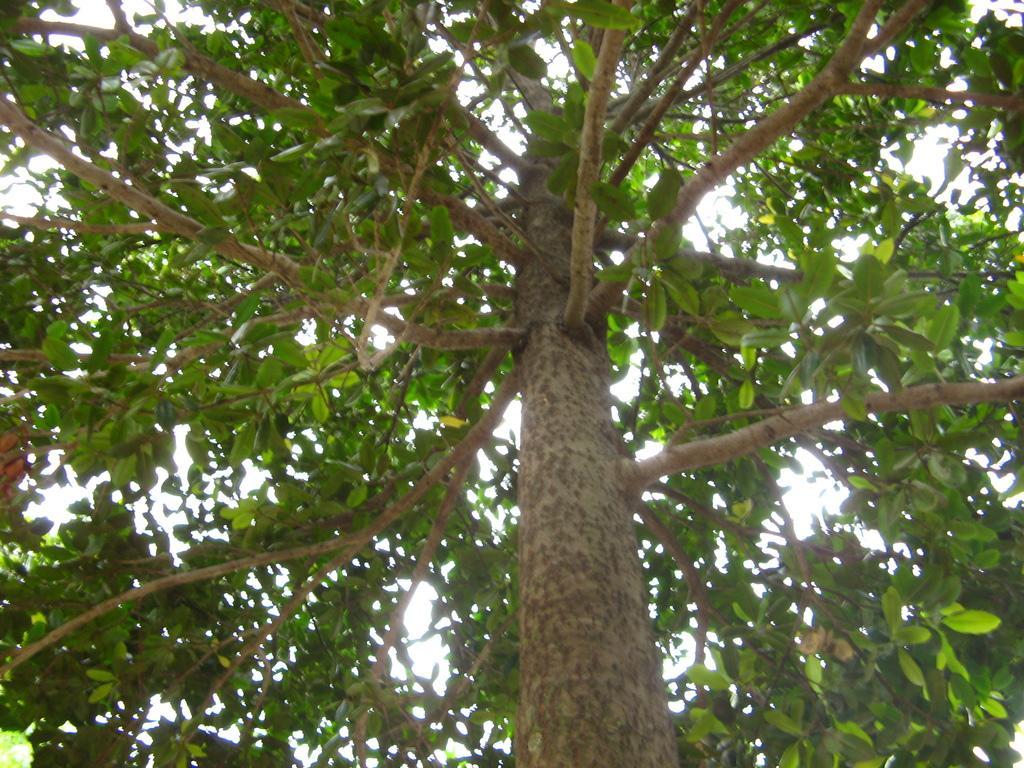Can you describe this image briefly? In this image I can see a tree which is green and brown in color. In the background I can see the sky. 